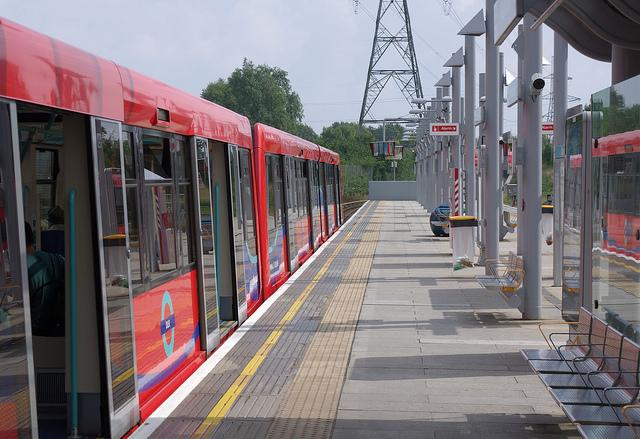What will the train do next? depart 